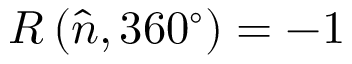Convert formula to latex. <formula><loc_0><loc_0><loc_500><loc_500>R \left ( { \hat { n } } , 3 6 0 ^ { \circ } \right ) = - 1</formula> 